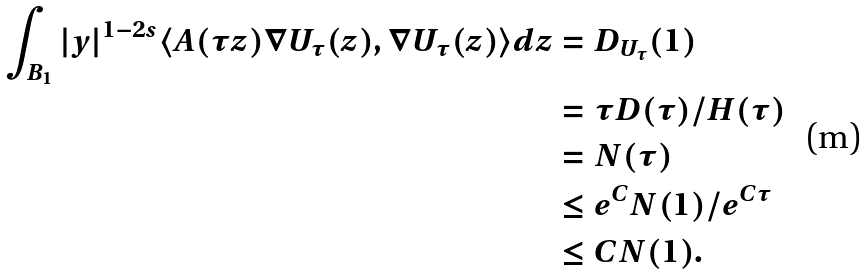Convert formula to latex. <formula><loc_0><loc_0><loc_500><loc_500>\int _ { B _ { 1 } } | y | ^ { 1 - 2 s } \langle A ( \tau z ) \nabla U _ { \tau } ( z ) , \nabla U _ { \tau } ( z ) \rangle d z & = D _ { U _ { \tau } } ( 1 ) \\ & = \tau D ( \tau ) / H ( \tau ) \\ & = N ( \tau ) \\ & \leq e ^ { C } N ( 1 ) / e ^ { C \tau } \\ & \leq C N ( 1 ) .</formula> 